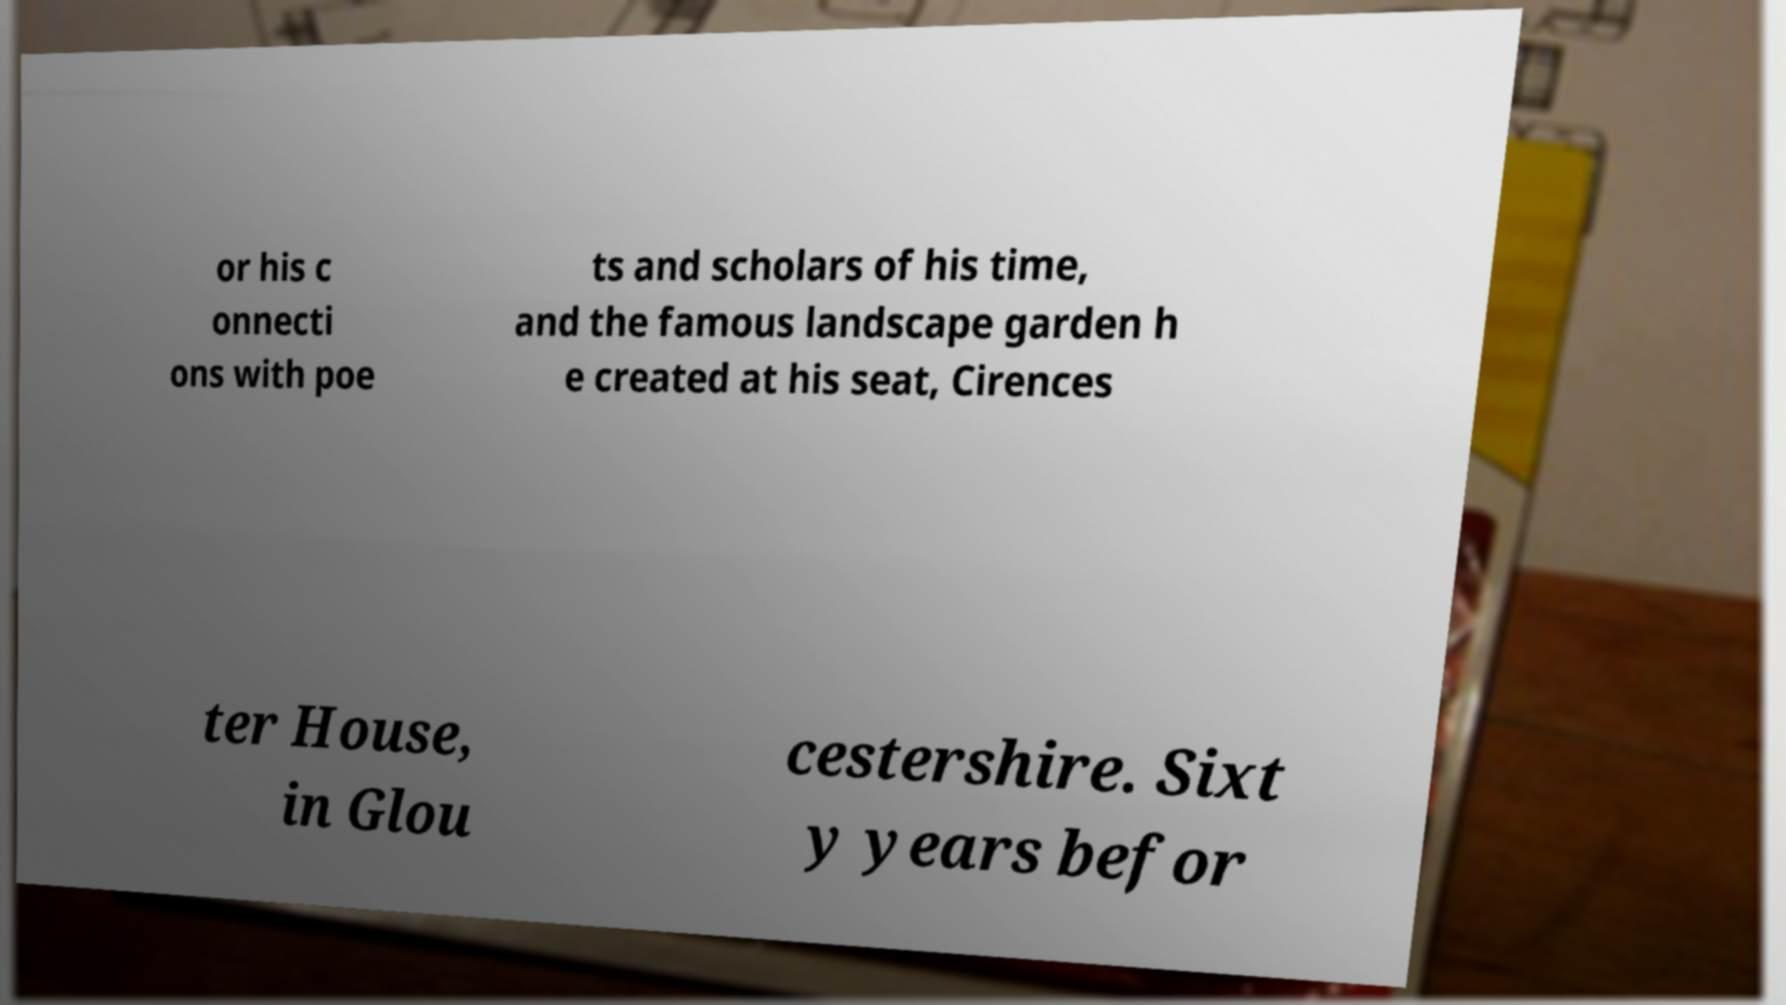Could you extract and type out the text from this image? or his c onnecti ons with poe ts and scholars of his time, and the famous landscape garden h e created at his seat, Cirences ter House, in Glou cestershire. Sixt y years befor 